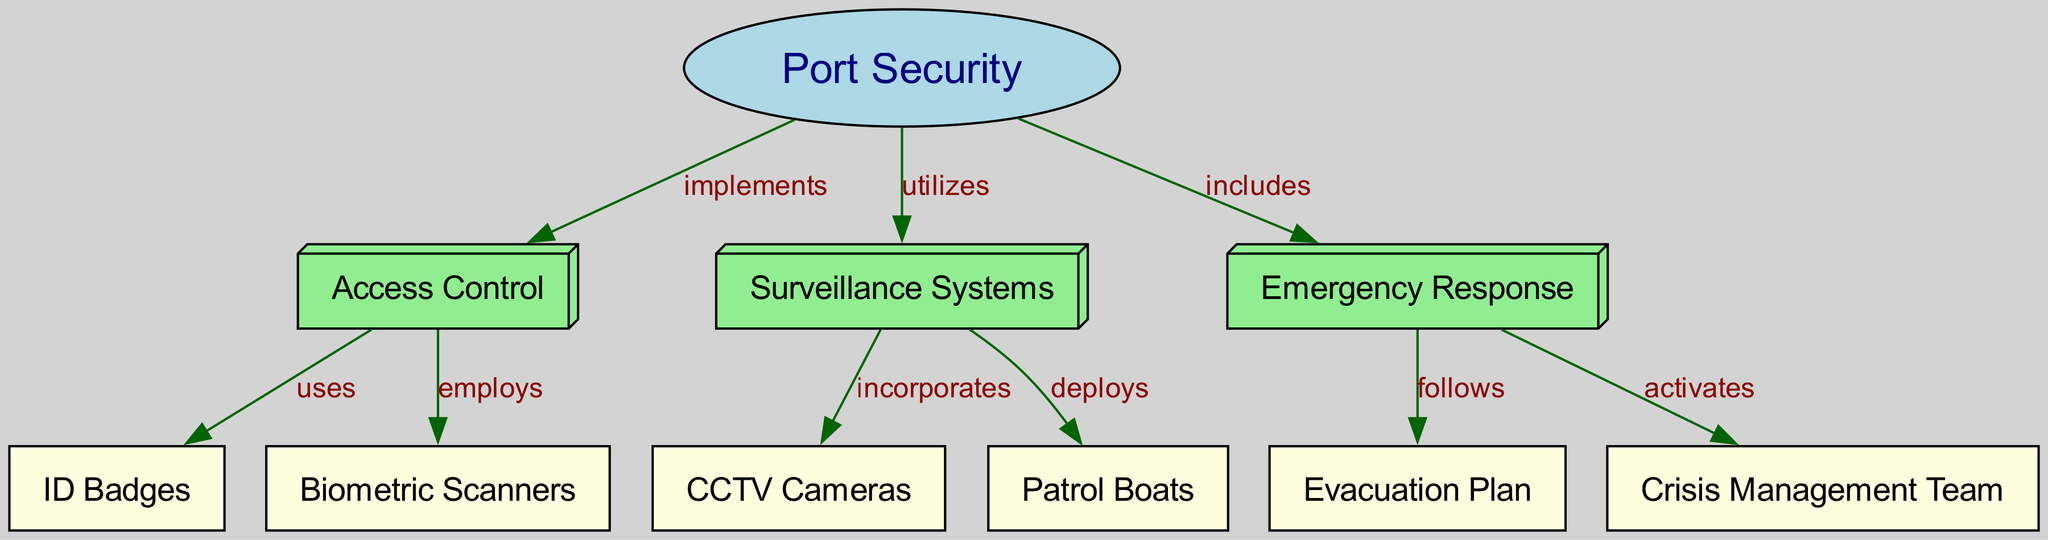What are the main elements of port security? The main elements of port security visible in the diagram are access control, surveillance systems, and emergency response. Each of these branches off from the central node labeled "Port Security," indicating they are key components of the overall security strategy.
Answer: access control, surveillance systems, emergency response How many nodes are there in the diagram? By counting the nodes labeled in the diagram, we find there are a total of 10 nodes, including the main element "Port Security" and its associated components and subcomponents.
Answer: 10 What system is utilized for surveillance? The diagram indicates that CCTV Cameras are incorporated into the surveillance systems as a method of monitoring the port area, thus revealing the specific tool used.
Answer: CCTV Cameras Which access control method uses biometric technology? The diagram shows that biometric scanners are employed as part of the access control measures designed to enhance security by verifying individual identities.
Answer: biometric scanners How does emergency response relate to evacuation procedures? The diagram specifies that the emergency response includes protocols like following an evacuation plan, establishing a direct link between these two elements in the context of preparedness.
Answer: follows What does the crisis management team do in an emergency? According to the diagram, the crisis management team is activated during emergencies, indicating their role in coordinating response efforts when incidents occur.
Answer: activates Which component of port security utilizes patrol boats? The diagram shows that patrol boats are deployed as part of the surveillance systems, indicating their function in monitoring and securing the waters surrounding the port.
Answer: deploys What type of access control does the diagram depict? The diagram displays access control as using ID badges and employing biometric scanners, which specifies the methods of granting access to the dockyard.
Answer: ID Badges, Biometric Scanners How many edges are represented in the diagram? The diagram has 9 edges representing various relationships and actions among the nodes, connecting components under the broader concept of port security.
Answer: 9 